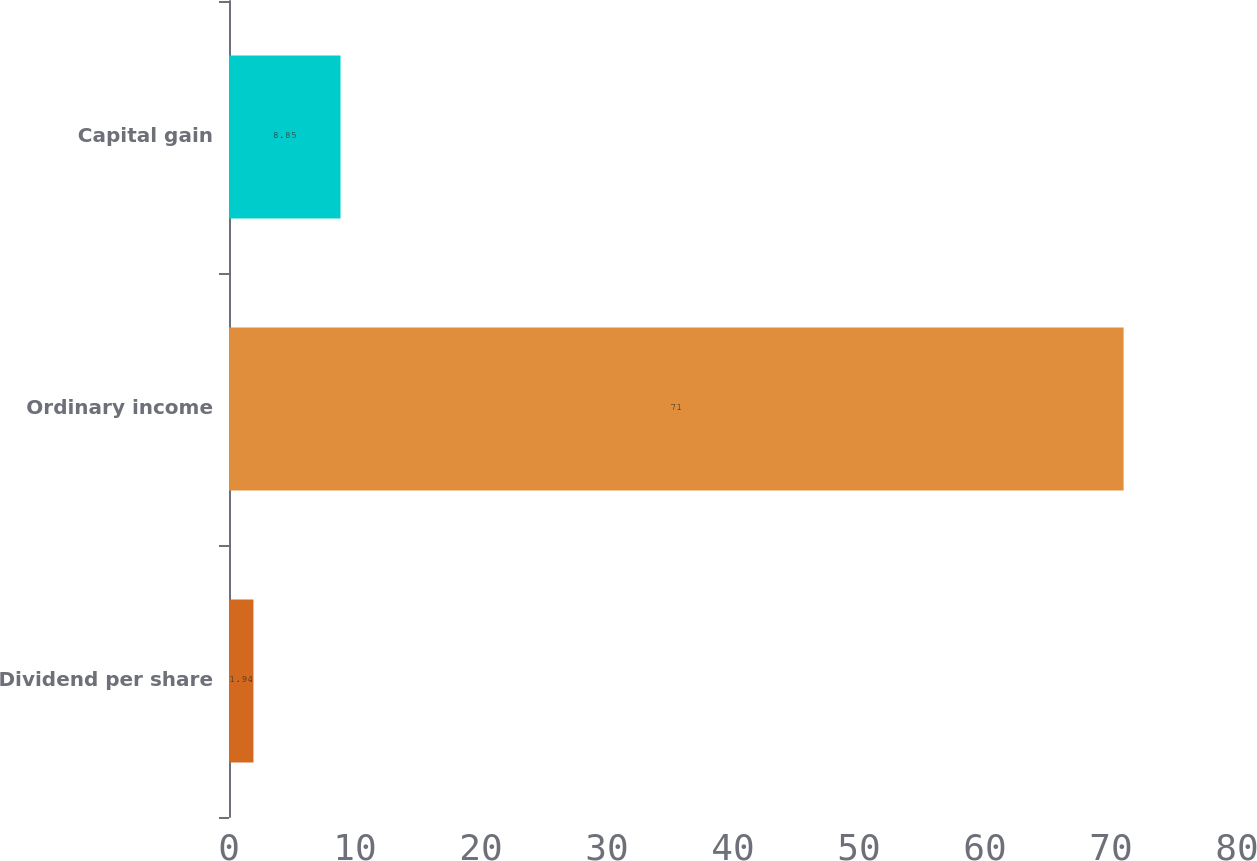Convert chart. <chart><loc_0><loc_0><loc_500><loc_500><bar_chart><fcel>Dividend per share<fcel>Ordinary income<fcel>Capital gain<nl><fcel>1.94<fcel>71<fcel>8.85<nl></chart> 